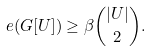<formula> <loc_0><loc_0><loc_500><loc_500>e ( G [ U ] ) \geq \beta \binom { | U | } { 2 } .</formula> 